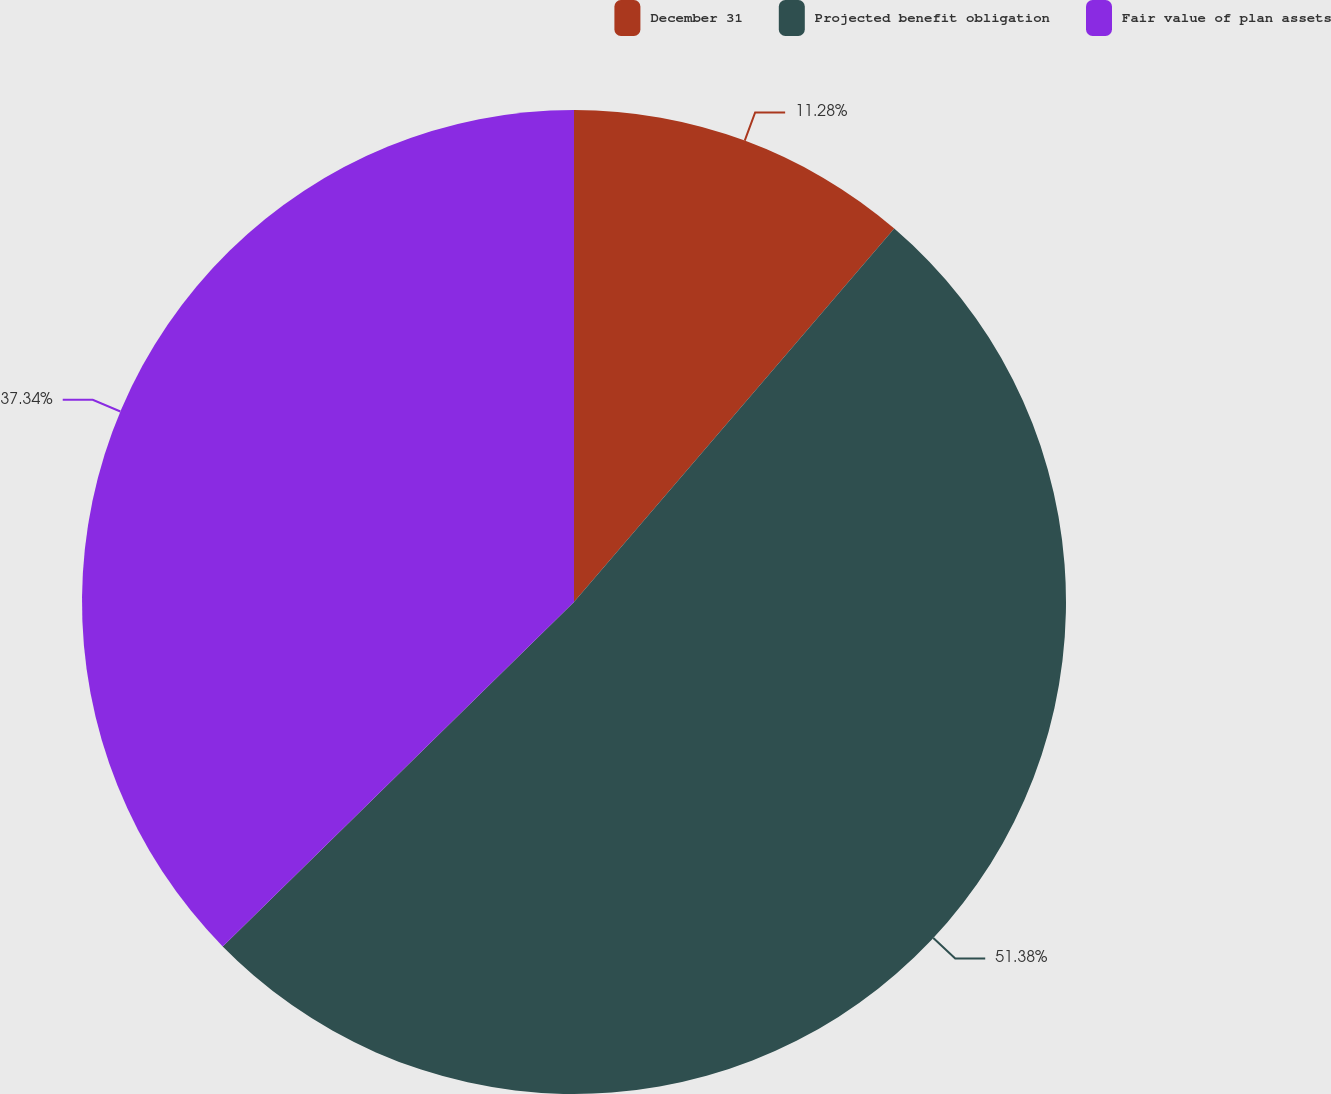Convert chart. <chart><loc_0><loc_0><loc_500><loc_500><pie_chart><fcel>December 31<fcel>Projected benefit obligation<fcel>Fair value of plan assets<nl><fcel>11.28%<fcel>51.37%<fcel>37.34%<nl></chart> 